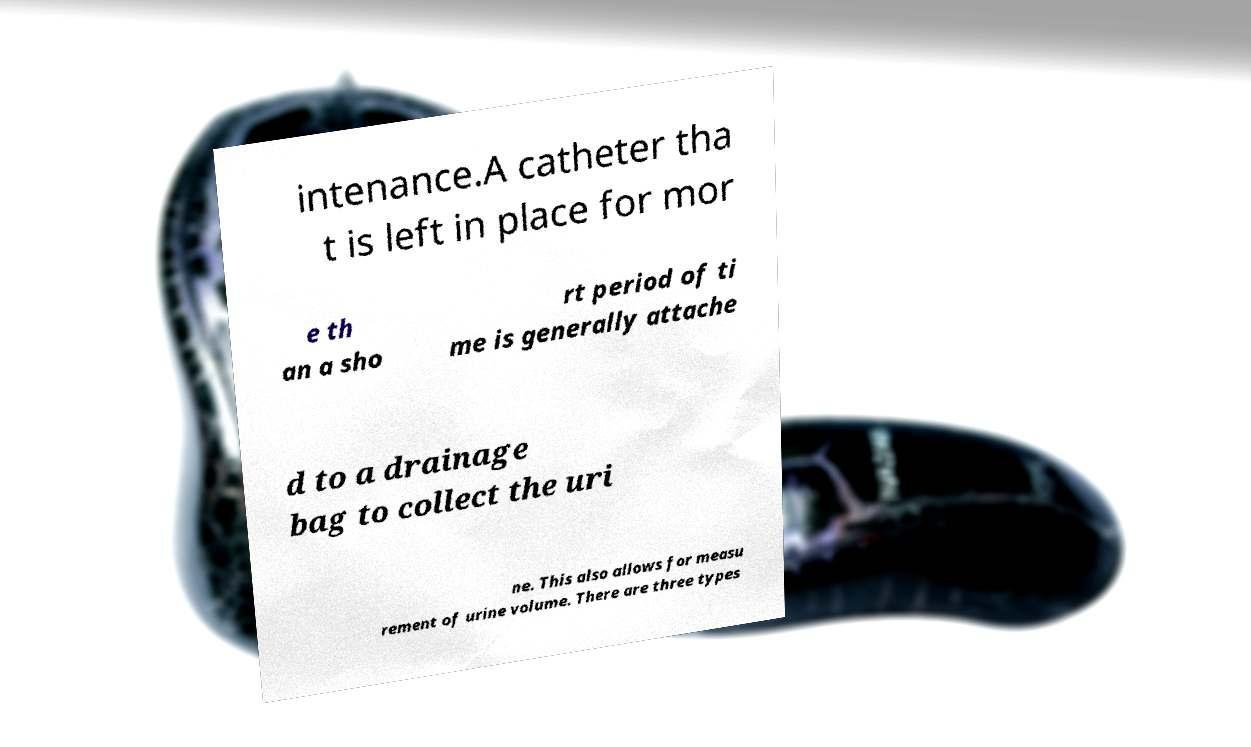Can you read and provide the text displayed in the image?This photo seems to have some interesting text. Can you extract and type it out for me? intenance.A catheter tha t is left in place for mor e th an a sho rt period of ti me is generally attache d to a drainage bag to collect the uri ne. This also allows for measu rement of urine volume. There are three types 